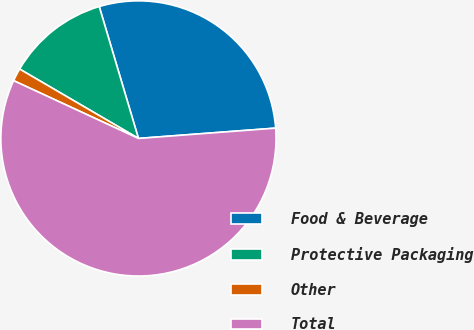Convert chart to OTSL. <chart><loc_0><loc_0><loc_500><loc_500><pie_chart><fcel>Food & Beverage<fcel>Protective Packaging<fcel>Other<fcel>Total<nl><fcel>28.41%<fcel>11.99%<fcel>1.51%<fcel>58.1%<nl></chart> 